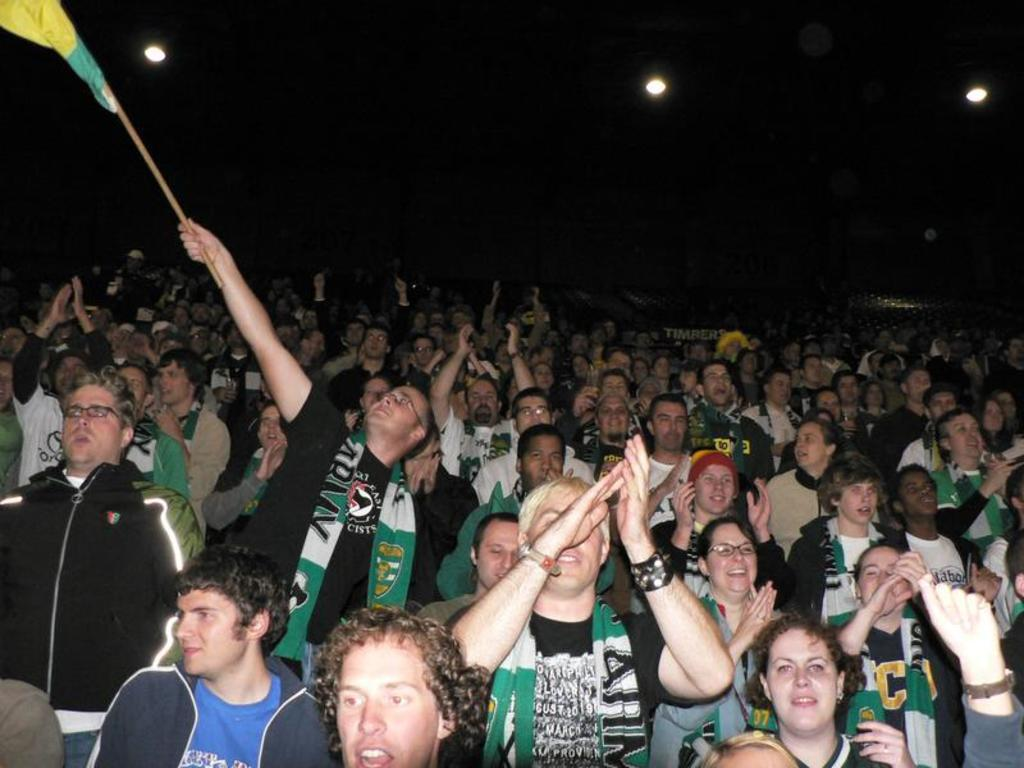What is the main subject of the image? The main subject of the image is a large crowd. How are the people in the crowd behaving? The people in the crowd are enjoying themselves and clapping. Can you describe any specific actions being performed by the people in the crowd? One person is flying a flag with their hand. What type of blood is visible on the comb in the image? There is no comb or blood present in the image. What type of drink is being passed around in the crowd? There is no drink being passed around in the image; the people are clapping and flying a flag. 